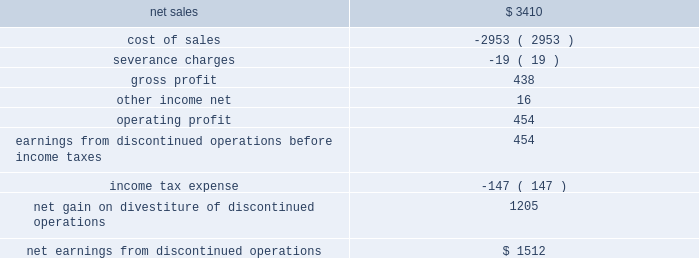As a result of the transaction , we recognized a net gain of approximately $ 1.3 billion , including $ 1.2 billion recognized in 2016 .
The net gain represents the $ 2.5 billion fair value of the shares of lockheed martin common stock exchanged and retired as part of the exchange offer , plus the $ 1.8 billion one-time special cash payment , less the net book value of the is&gs business of about $ 3.0 billion at august 16 , 2016 and other adjustments of about $ 100 million .
In 2017 , we recognized an additional gain of $ 73 million , which reflects certain post-closing adjustments , including certain tax adjustments and the final determination of net working capital .
We classified the operating results of our former is&gs business as discontinued operations in our consolidated financial statements in accordance with u.s .
Gaap , as the divestiture of this business represented a strategic shift that had a major effect on our operations and financial results .
However , the cash flows generated by the is&gs business have not been reclassified in our consolidated statements of cash flows as we retained this cash as part of the transaction .
The operating results , prior to the august 16 , 2016 divestiture date , of the is&gs business that have been reflected within net earnings from discontinued operations for the year ended december 31 , 2016 are as follows ( in millions ) : .
The operating results of the is&gs business reported as discontinued operations are different than the results previously reported for the is&gs business segment .
Results reported within net earnings from discontinued operations only include costs that were directly attributable to the is&gs business and exclude certain corporate overhead costs that were previously allocated to the is&gs business .
As a result , we reclassified $ 82 million in 2016 of corporate overhead costs from the is&gs business to other unallocated , net on our consolidated statement of earnings .
Additionally , we retained all assets and obligations related to the pension benefits earned by former is&gs business salaried employees through the date of divestiture .
Therefore , the non-service portion of net pension costs ( e.g. , interest cost , actuarial gains and losses and expected return on plan assets ) for these plans have been reclassified from the operating results of the is&gs business segment and reported as a reduction to the fas/cas pension adjustment .
These net pension costs were $ 54 million for the year ended december 31 , 2016 .
The service portion of net pension costs related to is&gs business 2019s salaried employees that transferred to leidos were included in the operating results of the is&gs business classified as discontinued operations because such costs are no longer incurred by us .
Significant severance charges related to the is&gs business were historically recorded at the lockheed martin corporate office .
These charges have been reclassified into the operating results of the is&gs business , classified as discontinued operations , and excluded from the operating results of our continuing operations .
The amount of severance charges reclassified were $ 19 million in 2016 .
Financial information related to cash flows generated by the is&gs business , such as depreciation and amortization , capital expenditures , and other non-cash items , included in our consolidated statement of cash flows for the years ended december 31 , 2016 were not significant. .
What is the gross profit margin? 
Computations: (438 / 3410)
Answer: 0.12845. 